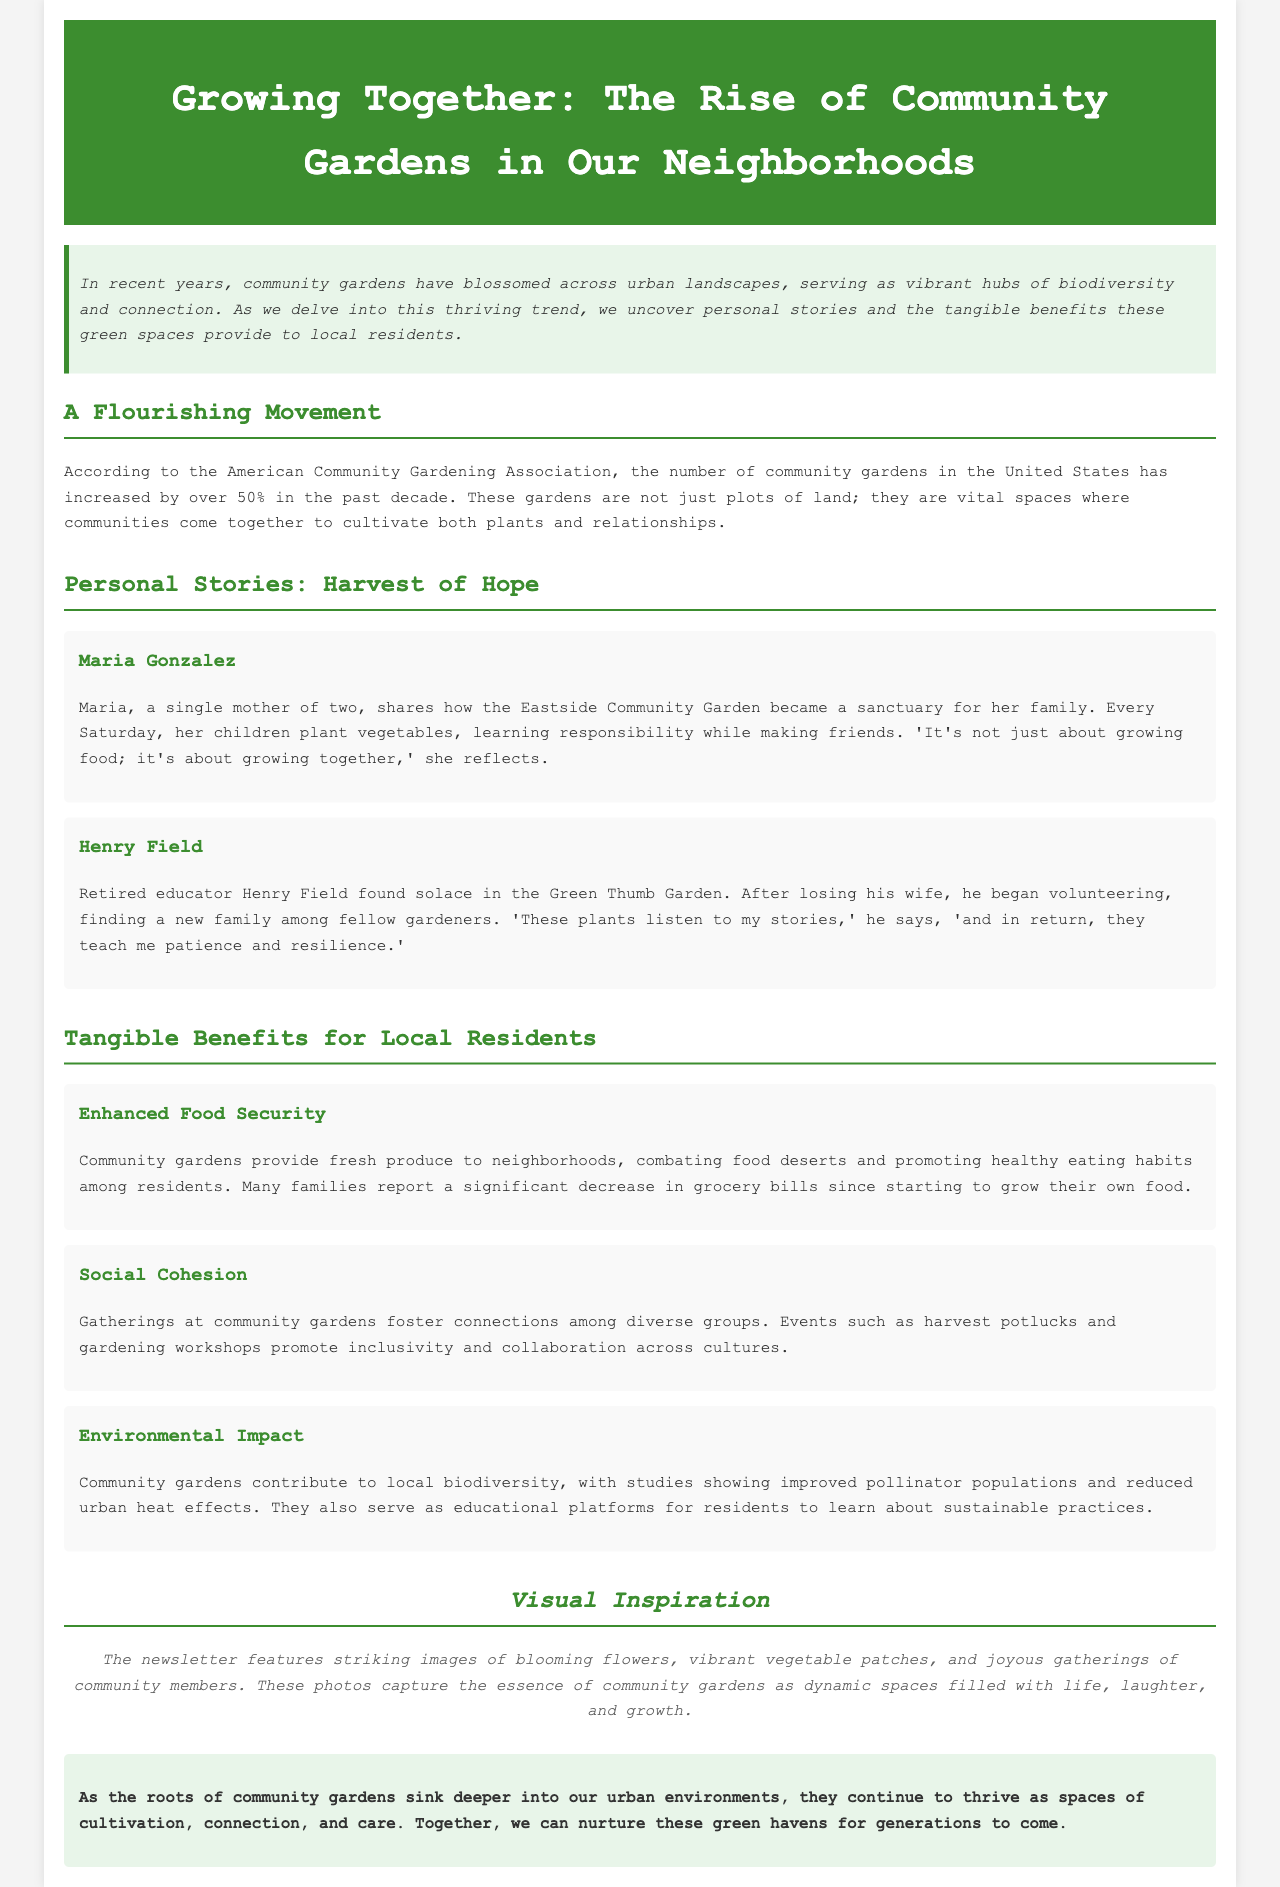What has increased by over 50%? The document states that the number of community gardens in the United States has increased by over 50% in the past decade.
Answer: community gardens Who is the single mother mentioned? Maria Gonzalez is the single mother of two who shares her experience in the Eastside Community Garden.
Answer: Maria Gonzalez What is one benefit of community gardens mentioned? The document lists multiple benefits, including enhanced food security, social cohesion, and environmental impact.
Answer: Enhanced Food Security What type of gatherings do community gardens host? The document mentions events such as harvest potlucks and gardening workshops that promote connections among diverse groups.
Answer: harvest potlucks Where does Henry Field volunteer? Henry Field found solace in the Green Thumb Garden where he began volunteering.
Answer: Green Thumb Garden What do community gardens contribute to local biodiversity? The document highlights that community gardens lead to improved pollinator populations and reduced urban heat effects.
Answer: improved pollinator populations What emotion does Maria associate with gardening? Maria reflects that gardening is not just about growing food; it’s also about fostering togetherness and relationships.
Answer: growing together What style of imagery accompanies the newsletter? The newsletter features striking images capturing the essence of community gardens filled with life and gatherings.
Answer: blooming flowers, vibrant vegetable patches 